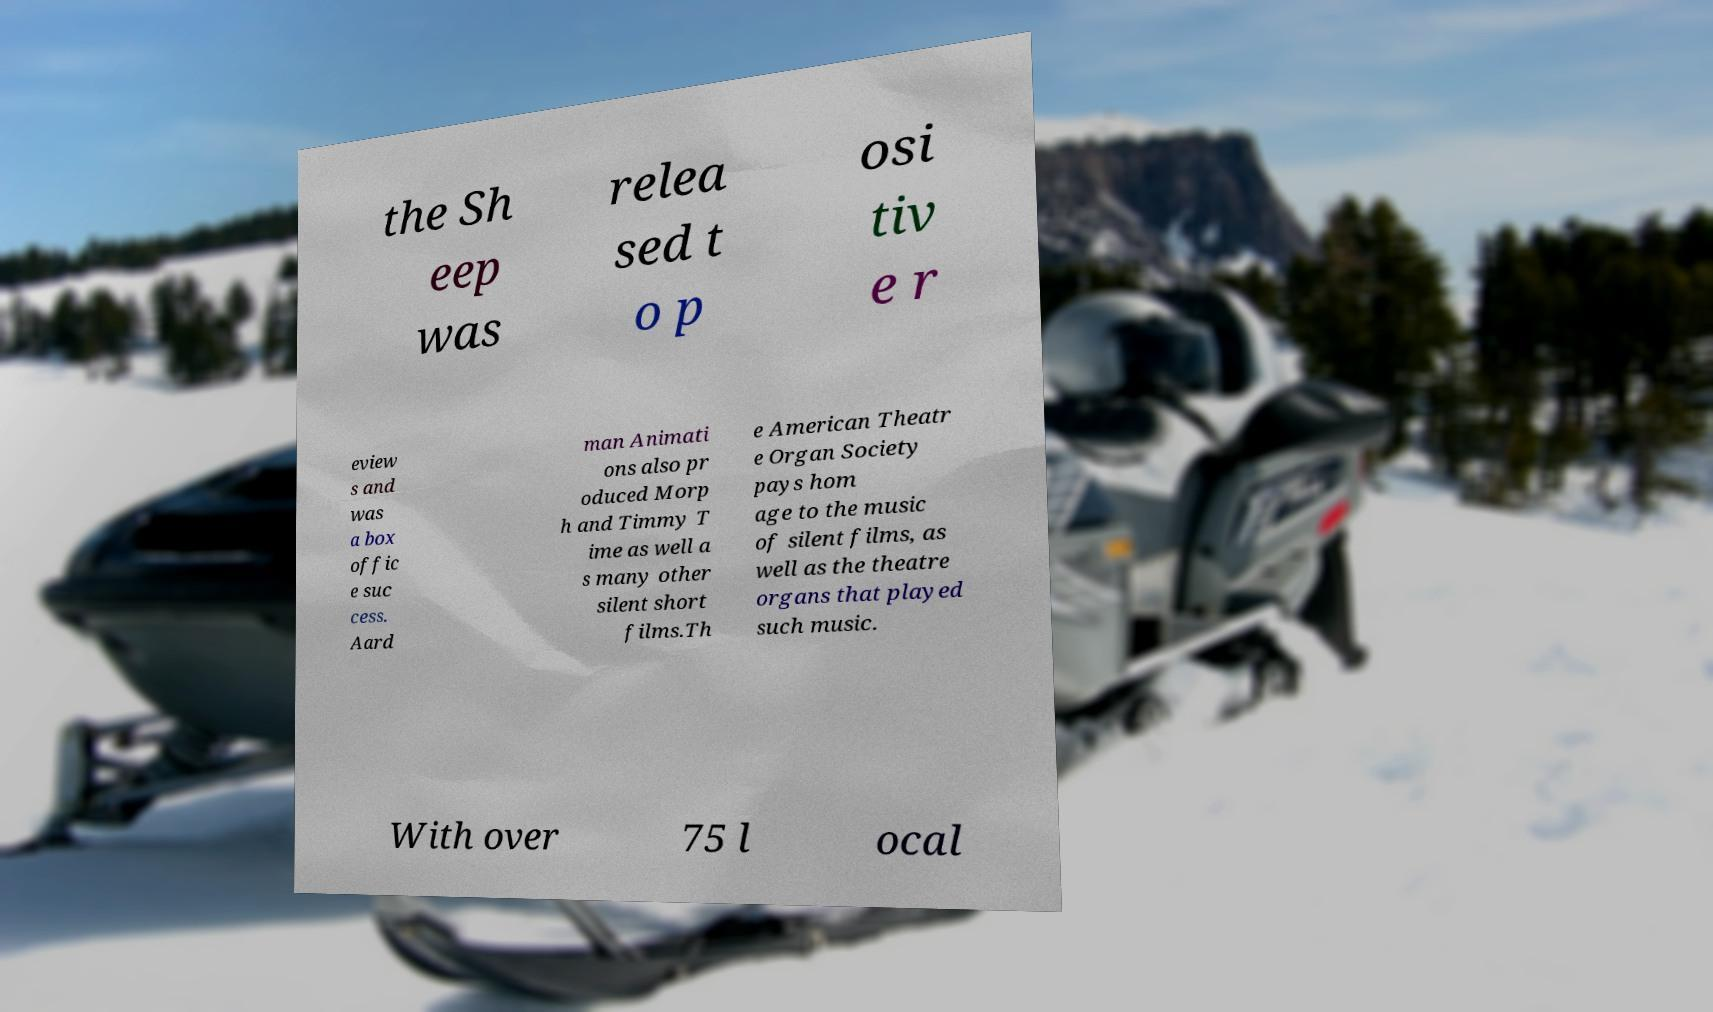There's text embedded in this image that I need extracted. Can you transcribe it verbatim? the Sh eep was relea sed t o p osi tiv e r eview s and was a box offic e suc cess. Aard man Animati ons also pr oduced Morp h and Timmy T ime as well a s many other silent short films.Th e American Theatr e Organ Society pays hom age to the music of silent films, as well as the theatre organs that played such music. With over 75 l ocal 